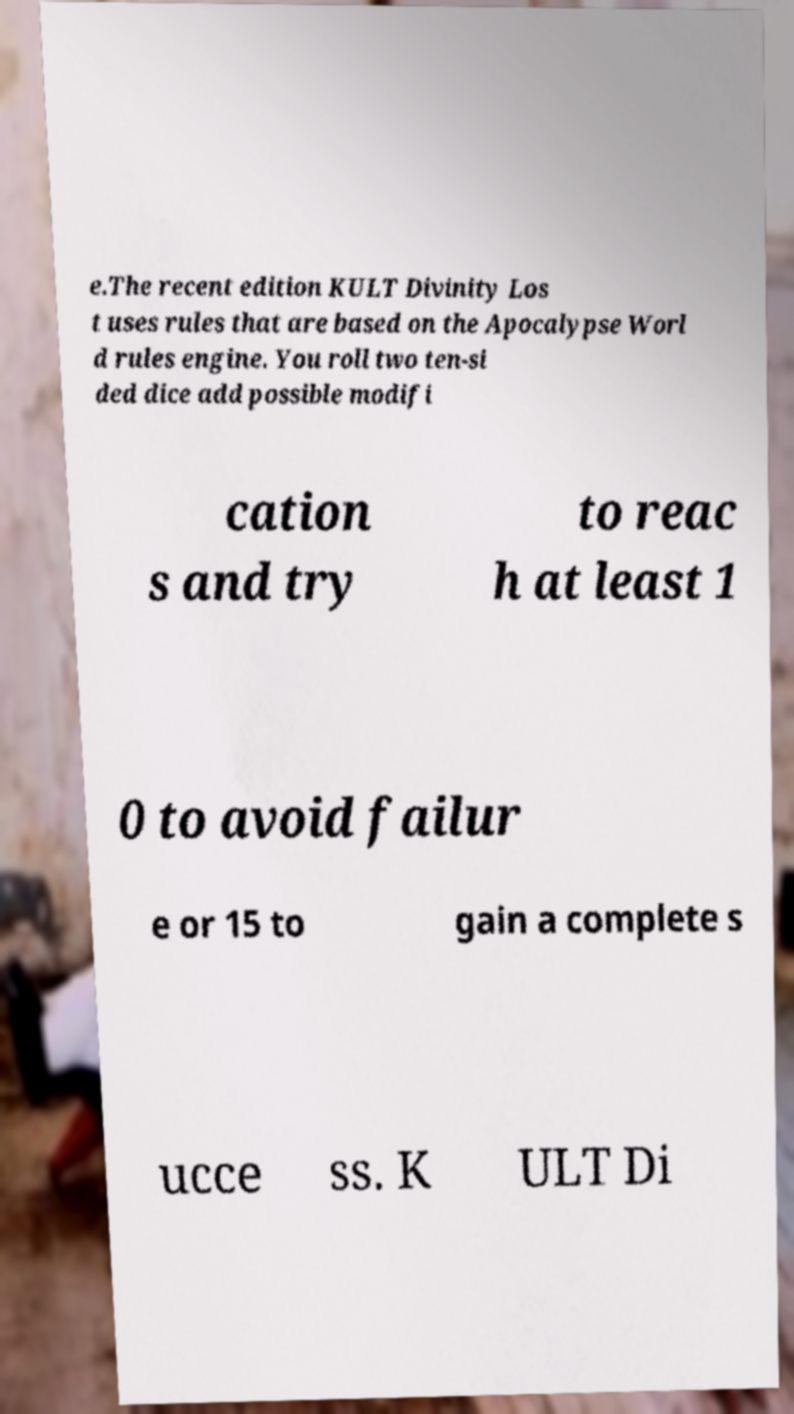Can you read and provide the text displayed in the image?This photo seems to have some interesting text. Can you extract and type it out for me? e.The recent edition KULT Divinity Los t uses rules that are based on the Apocalypse Worl d rules engine. You roll two ten-si ded dice add possible modifi cation s and try to reac h at least 1 0 to avoid failur e or 15 to gain a complete s ucce ss. K ULT Di 